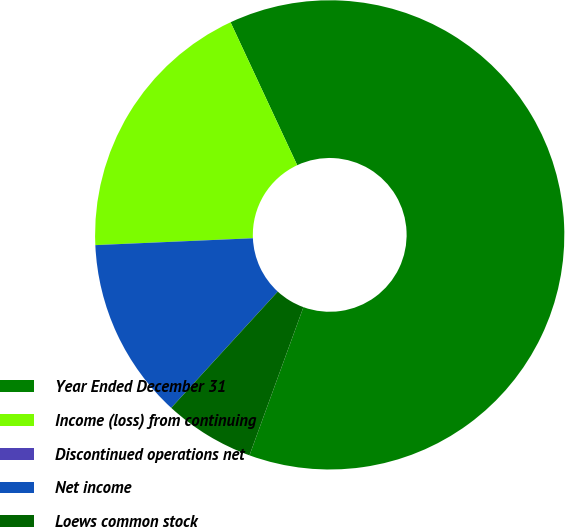<chart> <loc_0><loc_0><loc_500><loc_500><pie_chart><fcel>Year Ended December 31<fcel>Income (loss) from continuing<fcel>Discontinued operations net<fcel>Net income<fcel>Loews common stock<nl><fcel>62.5%<fcel>18.75%<fcel>0.0%<fcel>12.5%<fcel>6.25%<nl></chart> 